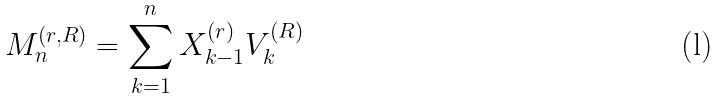Convert formula to latex. <formula><loc_0><loc_0><loc_500><loc_500>M _ { n } ^ { ( r , R ) } = \sum _ { k = 1 } ^ { n } X _ { k - 1 } ^ { ( r ) } V _ { k } ^ { ( R ) }</formula> 